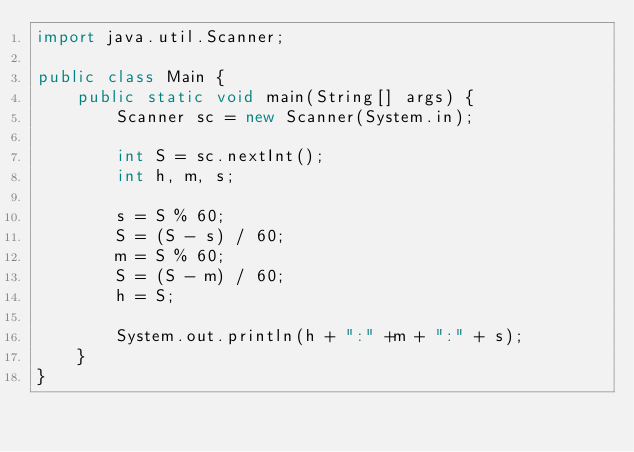Convert code to text. <code><loc_0><loc_0><loc_500><loc_500><_Java_>import java.util.Scanner;

public class Main {
    public static void main(String[] args) {
        Scanner sc = new Scanner(System.in);

        int S = sc.nextInt();
        int h, m, s;

        s = S % 60;
        S = (S - s) / 60;
        m = S % 60;
        S = (S - m) / 60;
        h = S;

        System.out.println(h + ":" +m + ":" + s);
    }
}

</code> 